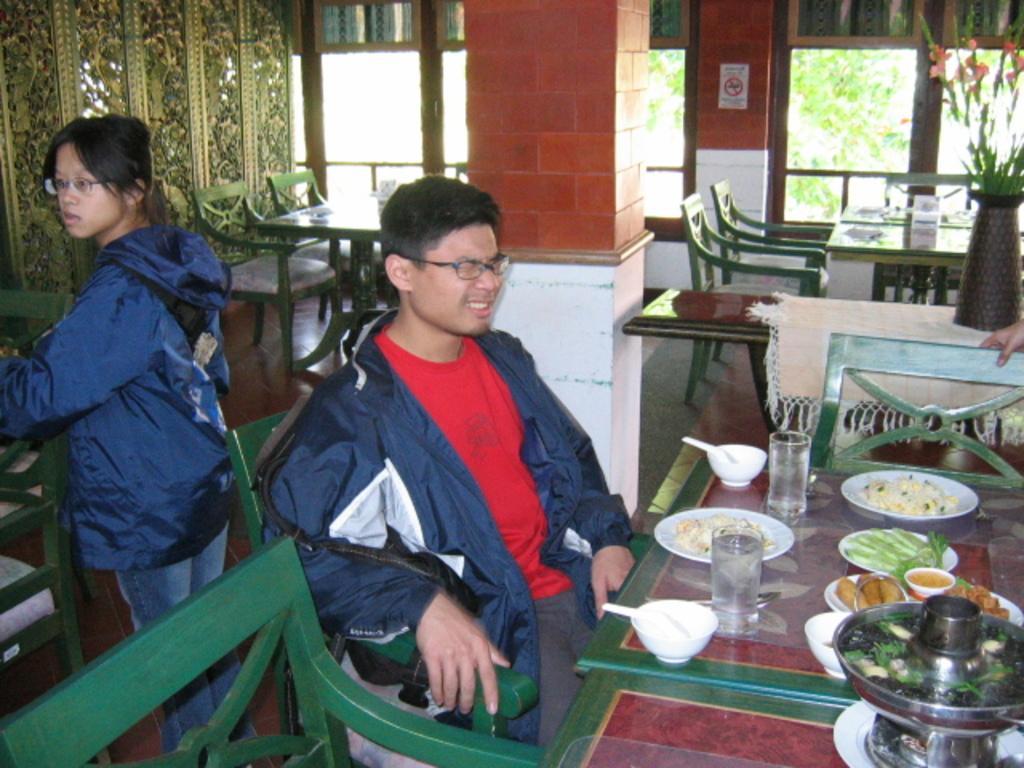Describe this image in one or two sentences. In this image i can see a man and a woman. The man is sitting on a chair in front of a table and the woman is standing on the floor. I can also see there are couple of chairs and tables. On the table we have couple of objects on it. 